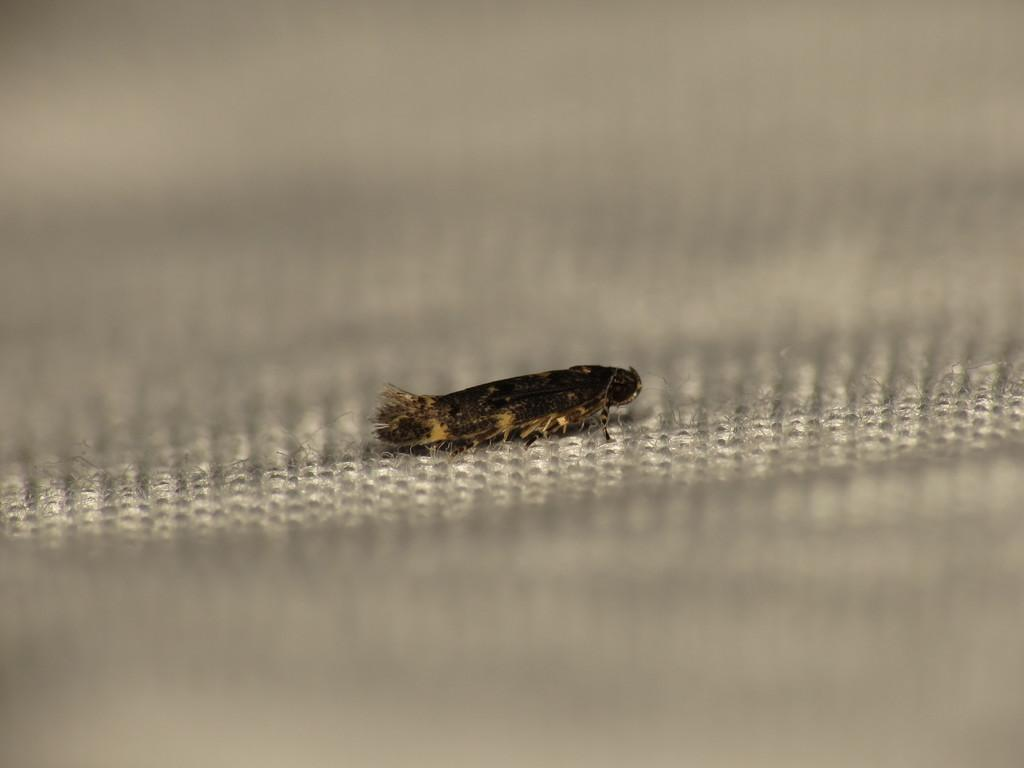What type of creature is present in the image? There is an insect in the image. Where is the insect located in the image? The insect is on a surface. How does the insect interact with the baby in the image? There is no baby present in the image, so the insect cannot interact with a baby. 